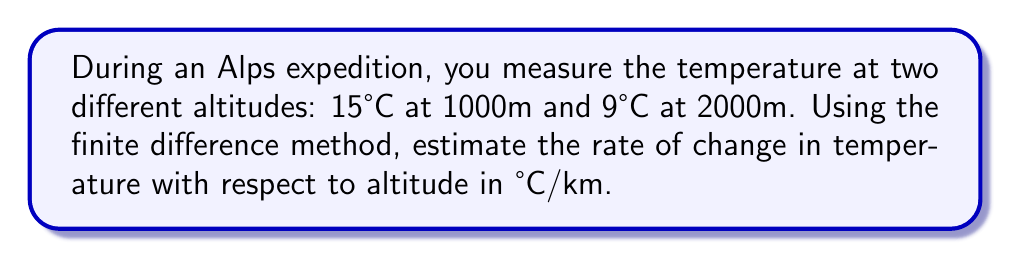Could you help me with this problem? To estimate the rate of change in temperature with respect to altitude, we can use the finite difference method. This method approximates the derivative (rate of change) using discrete data points.

1) Let's define our variables:
   $h_1 = 1000\text{m}$, $T_1 = 15°\text{C}$
   $h_2 = 2000\text{m}$, $T_2 = 9°\text{C}$

2) The finite difference formula for the rate of change is:

   $$\frac{\Delta T}{\Delta h} \approx \frac{T_2 - T_1}{h_2 - h_1}$$

3) Substituting our values:

   $$\frac{\Delta T}{\Delta h} \approx \frac{9°\text{C} - 15°\text{C}}{2000\text{m} - 1000\text{m}}$$

4) Simplify:

   $$\frac{\Delta T}{\Delta h} \approx \frac{-6°\text{C}}{1000\text{m}}$$

5) Convert meters to kilometers:

   $$\frac{\Delta T}{\Delta h} \approx \frac{-6°\text{C}}{1\text{km}} = -6°\text{C}/\text{km}$$

The negative sign indicates that temperature decreases as altitude increases.
Answer: $-6°\text{C}/\text{km}$ 